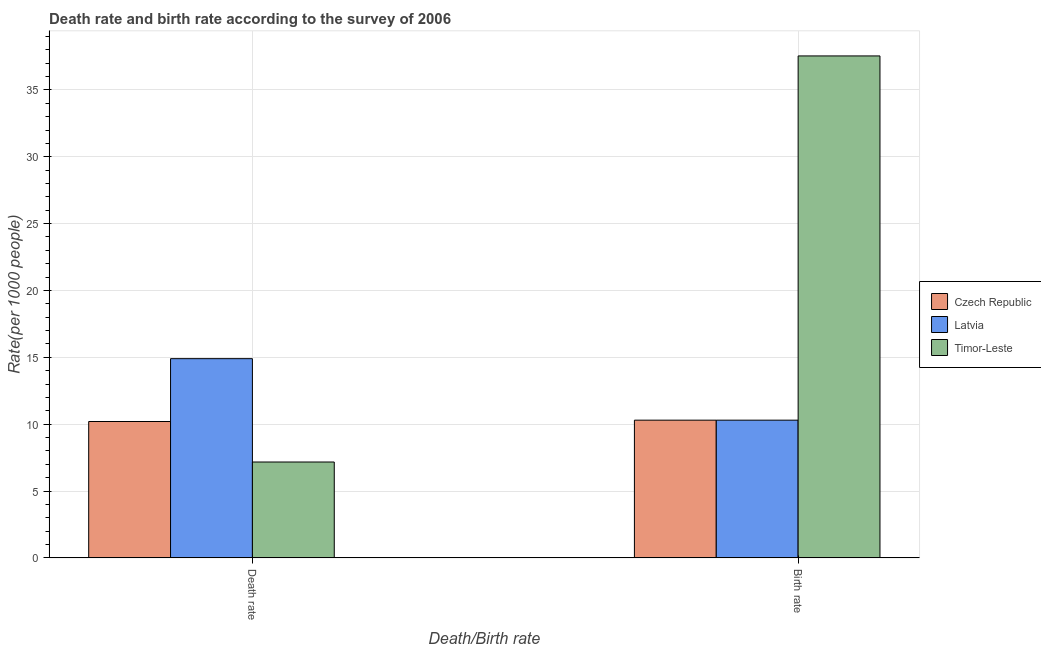How many different coloured bars are there?
Provide a succinct answer. 3. How many groups of bars are there?
Give a very brief answer. 2. Are the number of bars per tick equal to the number of legend labels?
Ensure brevity in your answer.  Yes. What is the label of the 1st group of bars from the left?
Give a very brief answer. Death rate. What is the death rate in Timor-Leste?
Your answer should be very brief. 7.17. Across all countries, what is the maximum birth rate?
Your response must be concise. 37.54. In which country was the death rate maximum?
Ensure brevity in your answer.  Latvia. In which country was the death rate minimum?
Provide a succinct answer. Timor-Leste. What is the total death rate in the graph?
Provide a short and direct response. 32.27. What is the difference between the birth rate in Timor-Leste and that in Latvia?
Your response must be concise. 27.24. What is the difference between the death rate in Latvia and the birth rate in Czech Republic?
Keep it short and to the point. 4.6. What is the average birth rate per country?
Give a very brief answer. 19.38. What is the difference between the birth rate and death rate in Czech Republic?
Offer a terse response. 0.1. In how many countries, is the birth rate greater than 11 ?
Give a very brief answer. 1. What is the ratio of the death rate in Timor-Leste to that in Latvia?
Keep it short and to the point. 0.48. Is the birth rate in Czech Republic less than that in Timor-Leste?
Make the answer very short. Yes. What does the 2nd bar from the left in Birth rate represents?
Offer a very short reply. Latvia. What does the 2nd bar from the right in Death rate represents?
Offer a terse response. Latvia. How many countries are there in the graph?
Offer a very short reply. 3. Does the graph contain any zero values?
Make the answer very short. No. Does the graph contain grids?
Provide a succinct answer. Yes. Where does the legend appear in the graph?
Your answer should be very brief. Center right. What is the title of the graph?
Keep it short and to the point. Death rate and birth rate according to the survey of 2006. What is the label or title of the X-axis?
Offer a terse response. Death/Birth rate. What is the label or title of the Y-axis?
Your response must be concise. Rate(per 1000 people). What is the Rate(per 1000 people) of Timor-Leste in Death rate?
Give a very brief answer. 7.17. What is the Rate(per 1000 people) of Timor-Leste in Birth rate?
Give a very brief answer. 37.54. Across all Death/Birth rate, what is the maximum Rate(per 1000 people) of Czech Republic?
Give a very brief answer. 10.3. Across all Death/Birth rate, what is the maximum Rate(per 1000 people) of Latvia?
Keep it short and to the point. 14.9. Across all Death/Birth rate, what is the maximum Rate(per 1000 people) of Timor-Leste?
Offer a very short reply. 37.54. Across all Death/Birth rate, what is the minimum Rate(per 1000 people) in Timor-Leste?
Your response must be concise. 7.17. What is the total Rate(per 1000 people) in Czech Republic in the graph?
Keep it short and to the point. 20.5. What is the total Rate(per 1000 people) in Latvia in the graph?
Your response must be concise. 25.2. What is the total Rate(per 1000 people) of Timor-Leste in the graph?
Offer a very short reply. 44.71. What is the difference between the Rate(per 1000 people) in Czech Republic in Death rate and that in Birth rate?
Provide a short and direct response. -0.1. What is the difference between the Rate(per 1000 people) in Latvia in Death rate and that in Birth rate?
Make the answer very short. 4.6. What is the difference between the Rate(per 1000 people) in Timor-Leste in Death rate and that in Birth rate?
Keep it short and to the point. -30.37. What is the difference between the Rate(per 1000 people) of Czech Republic in Death rate and the Rate(per 1000 people) of Latvia in Birth rate?
Your answer should be very brief. -0.1. What is the difference between the Rate(per 1000 people) of Czech Republic in Death rate and the Rate(per 1000 people) of Timor-Leste in Birth rate?
Provide a succinct answer. -27.34. What is the difference between the Rate(per 1000 people) in Latvia in Death rate and the Rate(per 1000 people) in Timor-Leste in Birth rate?
Your answer should be compact. -22.64. What is the average Rate(per 1000 people) of Czech Republic per Death/Birth rate?
Your answer should be compact. 10.25. What is the average Rate(per 1000 people) of Timor-Leste per Death/Birth rate?
Ensure brevity in your answer.  22.36. What is the difference between the Rate(per 1000 people) of Czech Republic and Rate(per 1000 people) of Timor-Leste in Death rate?
Offer a very short reply. 3.03. What is the difference between the Rate(per 1000 people) of Latvia and Rate(per 1000 people) of Timor-Leste in Death rate?
Ensure brevity in your answer.  7.73. What is the difference between the Rate(per 1000 people) of Czech Republic and Rate(per 1000 people) of Timor-Leste in Birth rate?
Provide a succinct answer. -27.24. What is the difference between the Rate(per 1000 people) in Latvia and Rate(per 1000 people) in Timor-Leste in Birth rate?
Keep it short and to the point. -27.24. What is the ratio of the Rate(per 1000 people) in Czech Republic in Death rate to that in Birth rate?
Give a very brief answer. 0.99. What is the ratio of the Rate(per 1000 people) of Latvia in Death rate to that in Birth rate?
Keep it short and to the point. 1.45. What is the ratio of the Rate(per 1000 people) of Timor-Leste in Death rate to that in Birth rate?
Provide a succinct answer. 0.19. What is the difference between the highest and the second highest Rate(per 1000 people) of Timor-Leste?
Offer a terse response. 30.37. What is the difference between the highest and the lowest Rate(per 1000 people) of Czech Republic?
Keep it short and to the point. 0.1. What is the difference between the highest and the lowest Rate(per 1000 people) in Latvia?
Keep it short and to the point. 4.6. What is the difference between the highest and the lowest Rate(per 1000 people) of Timor-Leste?
Give a very brief answer. 30.37. 